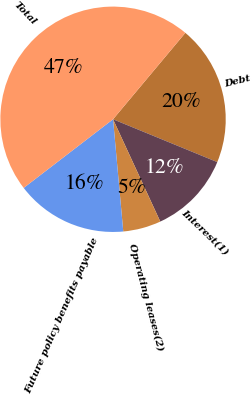Convert chart to OTSL. <chart><loc_0><loc_0><loc_500><loc_500><pie_chart><fcel>Debt<fcel>Interest(1)<fcel>Operating leases(2)<fcel>Future policy benefits payable<fcel>Total<nl><fcel>20.12%<fcel>11.91%<fcel>5.44%<fcel>16.02%<fcel>46.51%<nl></chart> 